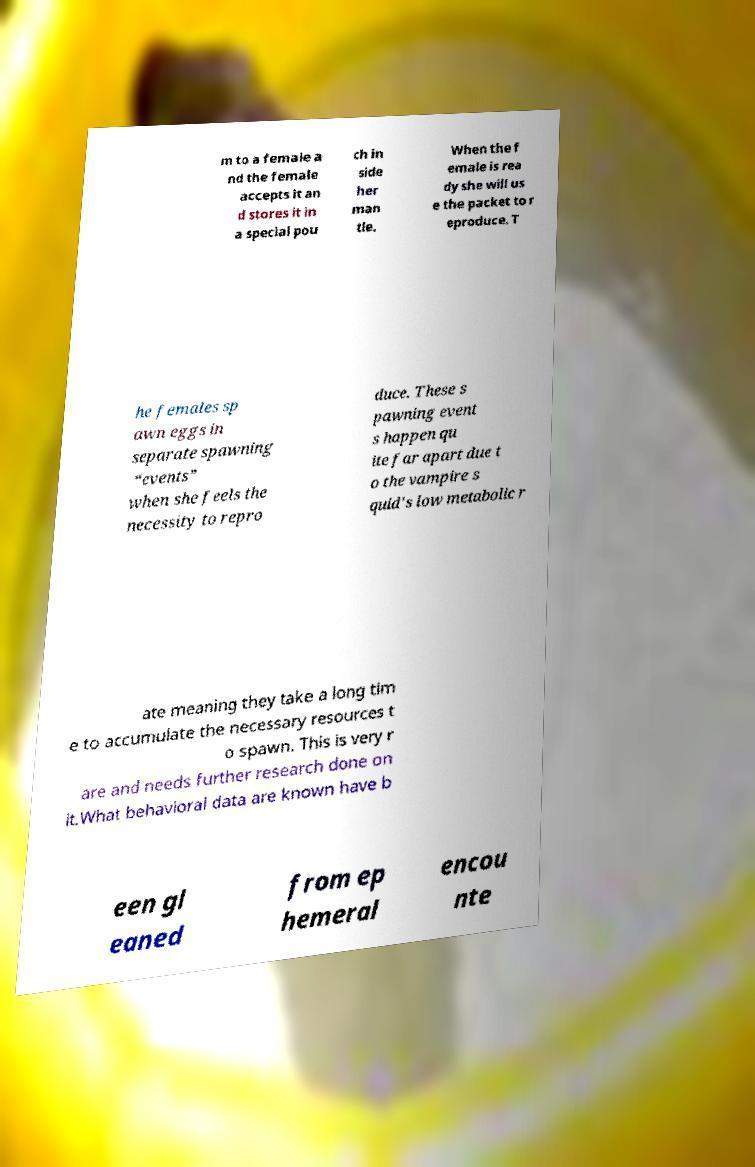For documentation purposes, I need the text within this image transcribed. Could you provide that? m to a female a nd the female accepts it an d stores it in a special pou ch in side her man tle. When the f emale is rea dy she will us e the packet to r eproduce. T he females sp awn eggs in separate spawning “events” when she feels the necessity to repro duce. These s pawning event s happen qu ite far apart due t o the vampire s quid's low metabolic r ate meaning they take a long tim e to accumulate the necessary resources t o spawn. This is very r are and needs further research done on it.What behavioral data are known have b een gl eaned from ep hemeral encou nte 